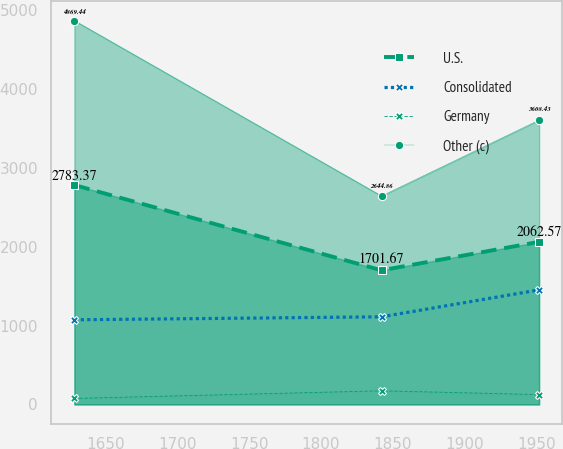Convert chart to OTSL. <chart><loc_0><loc_0><loc_500><loc_500><line_chart><ecel><fcel>U.S.<fcel>Consolidated<fcel>Germany<fcel>Other (c)<nl><fcel>1628.26<fcel>2783.37<fcel>1073.82<fcel>76.26<fcel>4869.44<nl><fcel>1842.22<fcel>1701.67<fcel>1111.77<fcel>173.07<fcel>2644.86<nl><fcel>1951.99<fcel>2062.57<fcel>1453.33<fcel>124.99<fcel>3608.43<nl></chart> 